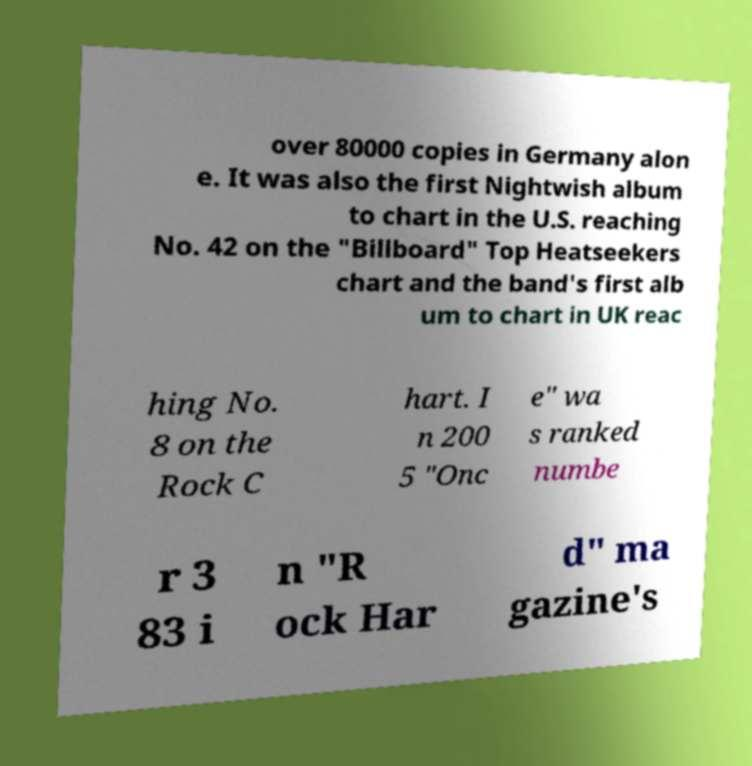I need the written content from this picture converted into text. Can you do that? over 80000 copies in Germany alon e. It was also the first Nightwish album to chart in the U.S. reaching No. 42 on the "Billboard" Top Heatseekers chart and the band's first alb um to chart in UK reac hing No. 8 on the Rock C hart. I n 200 5 "Onc e" wa s ranked numbe r 3 83 i n "R ock Har d" ma gazine's 